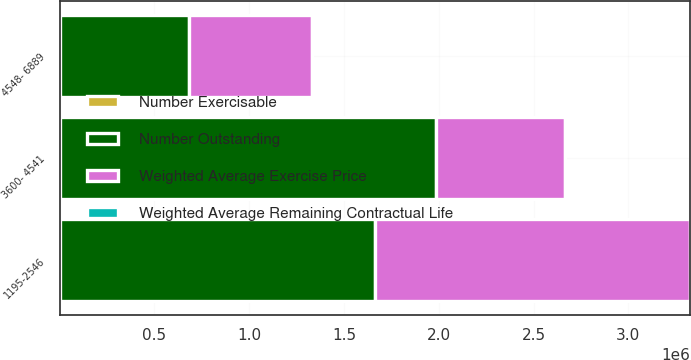<chart> <loc_0><loc_0><loc_500><loc_500><stacked_bar_chart><ecel><fcel>1195-2546<fcel>3600- 4541<fcel>4548- 6889<nl><fcel>Number Outstanding<fcel>1.66329e+06<fcel>1.98343e+06<fcel>682065<nl><fcel>Number Exercisable<fcel>5.86<fcel>8.75<fcel>8.1<nl><fcel>Weighted Average Remaining Contractual Life<fcel>20.22<fcel>38.79<fcel>49.9<nl><fcel>Weighted Average Exercise Price<fcel>1.66259e+06<fcel>679740<fcel>650565<nl></chart> 